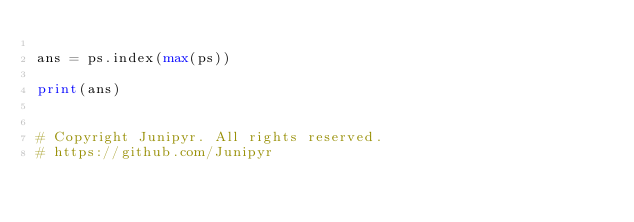<code> <loc_0><loc_0><loc_500><loc_500><_Python_>        
ans = ps.index(max(ps))

print(ans)


# Copyright Junipyr. All rights reserved.
# https://github.com/Junipyr</code> 